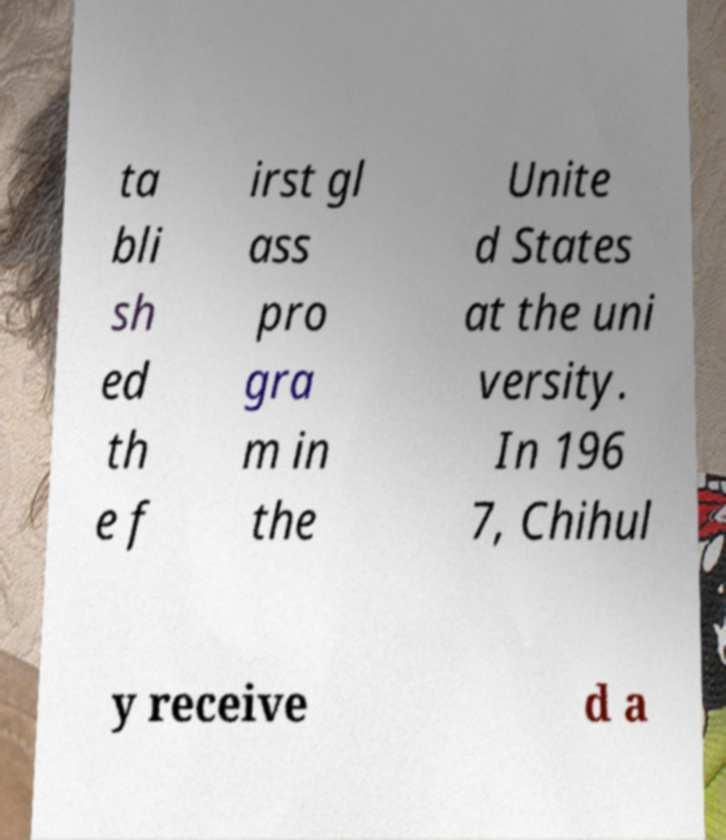Please identify and transcribe the text found in this image. ta bli sh ed th e f irst gl ass pro gra m in the Unite d States at the uni versity. In 196 7, Chihul y receive d a 